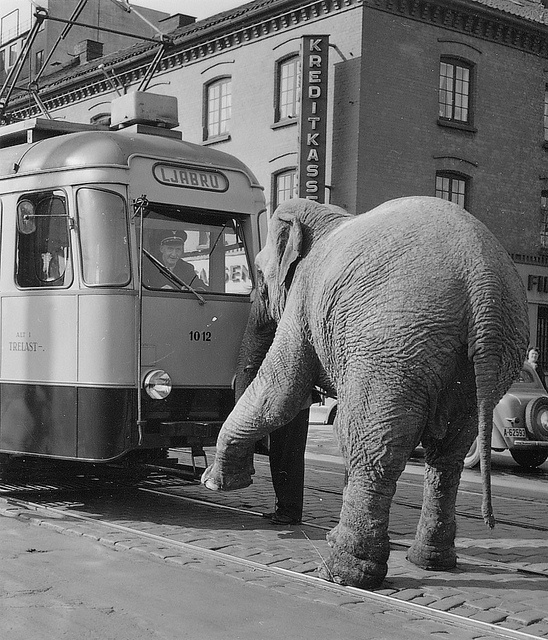Describe the objects in this image and their specific colors. I can see bus in white, gray, black, darkgray, and lightgray tones, train in white, gray, black, darkgray, and lightgray tones, elephant in white, darkgray, black, gray, and lightgray tones, car in white, black, gray, darkgray, and lightgray tones, and people in white, gray, black, darkgray, and lightgray tones in this image. 